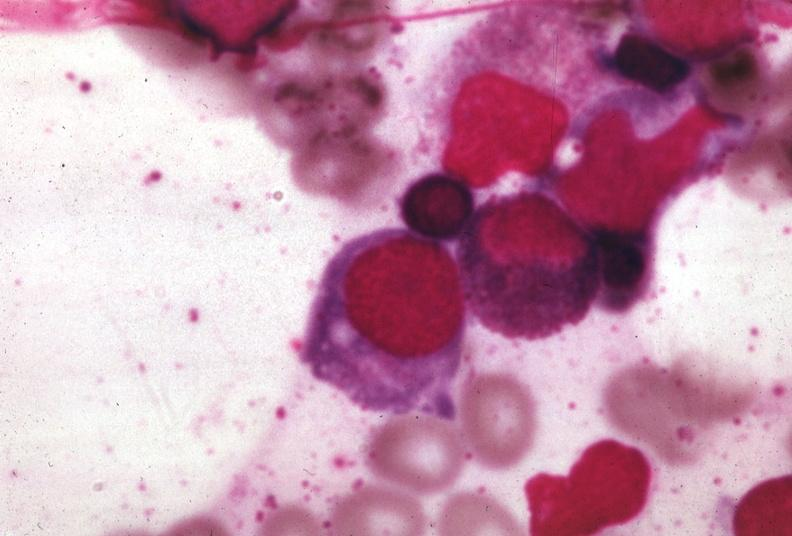s megaloblasts pernicious anemia present?
Answer the question using a single word or phrase. Yes 